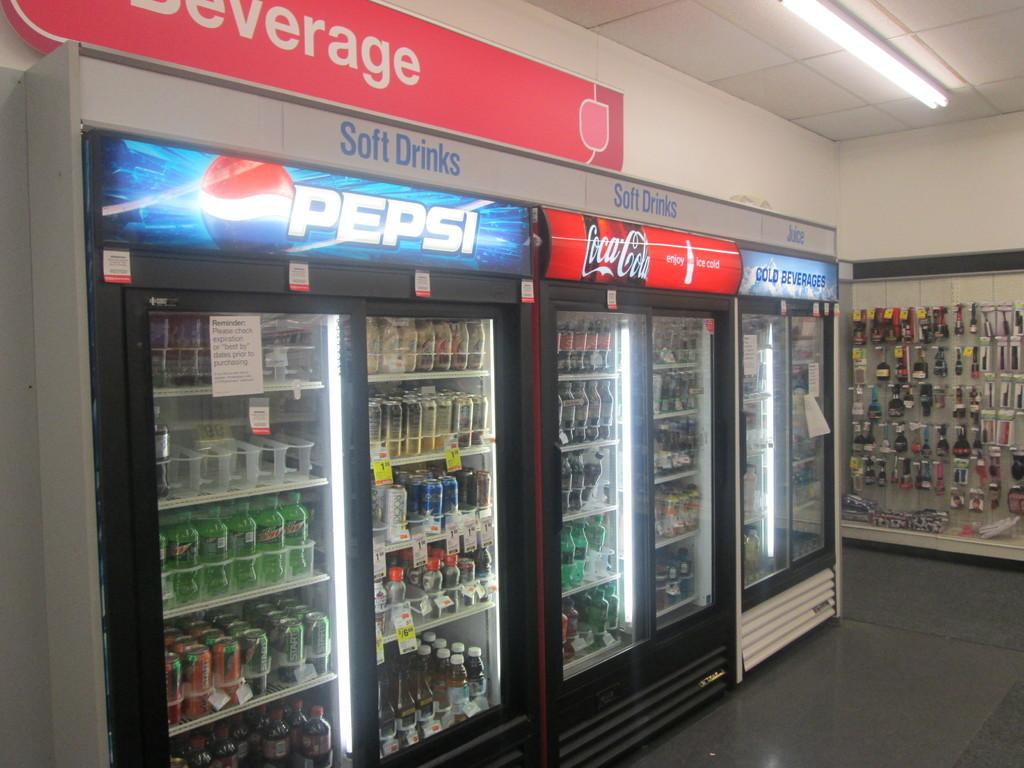<image>
Render a clear and concise summary of the photo. a Pepsi fridge with some sodas inside of it 